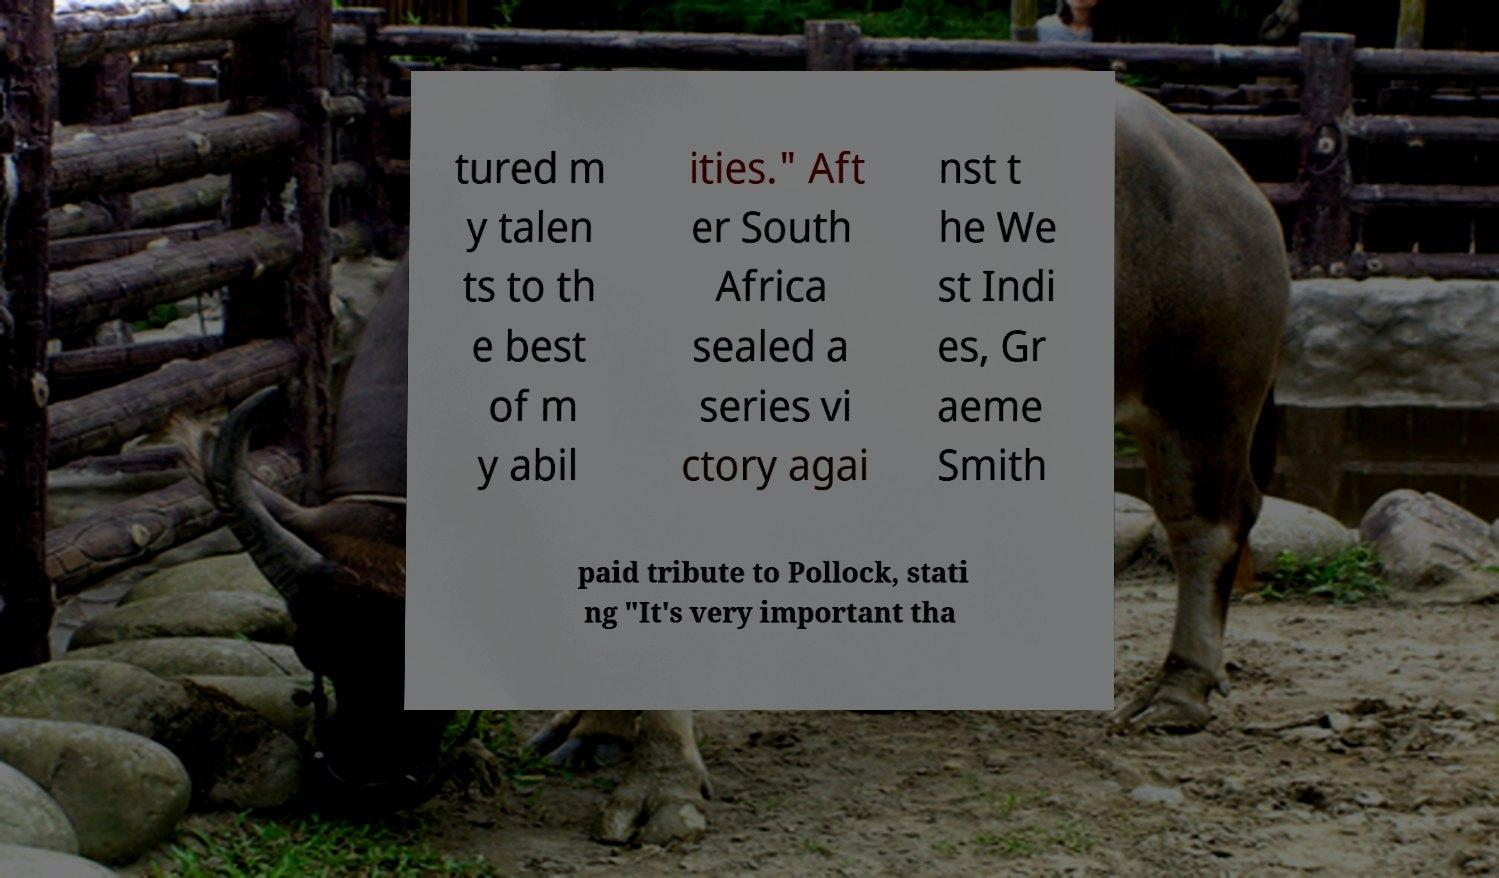Could you extract and type out the text from this image? tured m y talen ts to th e best of m y abil ities." Aft er South Africa sealed a series vi ctory agai nst t he We st Indi es, Gr aeme Smith paid tribute to Pollock, stati ng "It's very important tha 